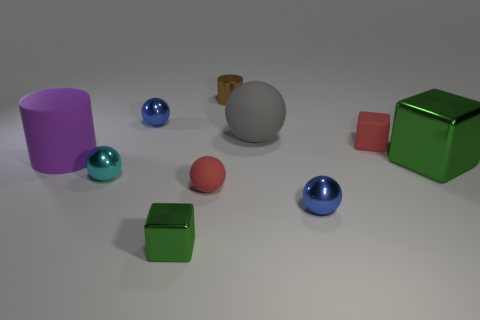Are the shapes in this image common in everyday objects? Yes, the shapes in the image do resemble common everyday objects. Cylinders and spheres are frequently seen in items like cans, balls, and ornaments, while cubes are reminiscent of boxes and dice. The variety of shapes provides a simple yet informative representation of geometric forms we encounter daily. 